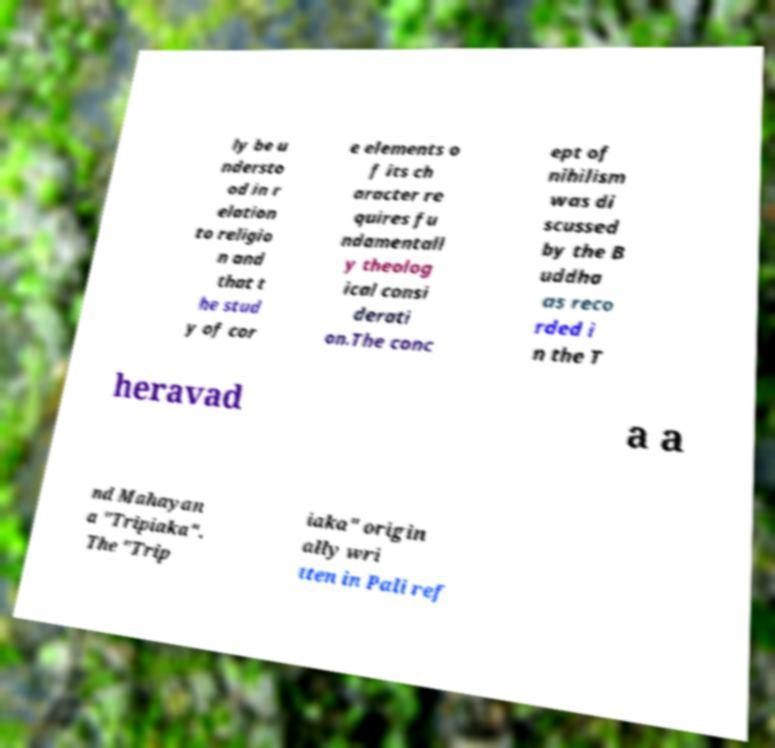What messages or text are displayed in this image? I need them in a readable, typed format. ly be u ndersto od in r elation to religio n and that t he stud y of cor e elements o f its ch aracter re quires fu ndamentall y theolog ical consi derati on.The conc ept of nihilism was di scussed by the B uddha as reco rded i n the T heravad a a nd Mahayan a "Tripiaka". The "Trip iaka" origin ally wri tten in Pali ref 